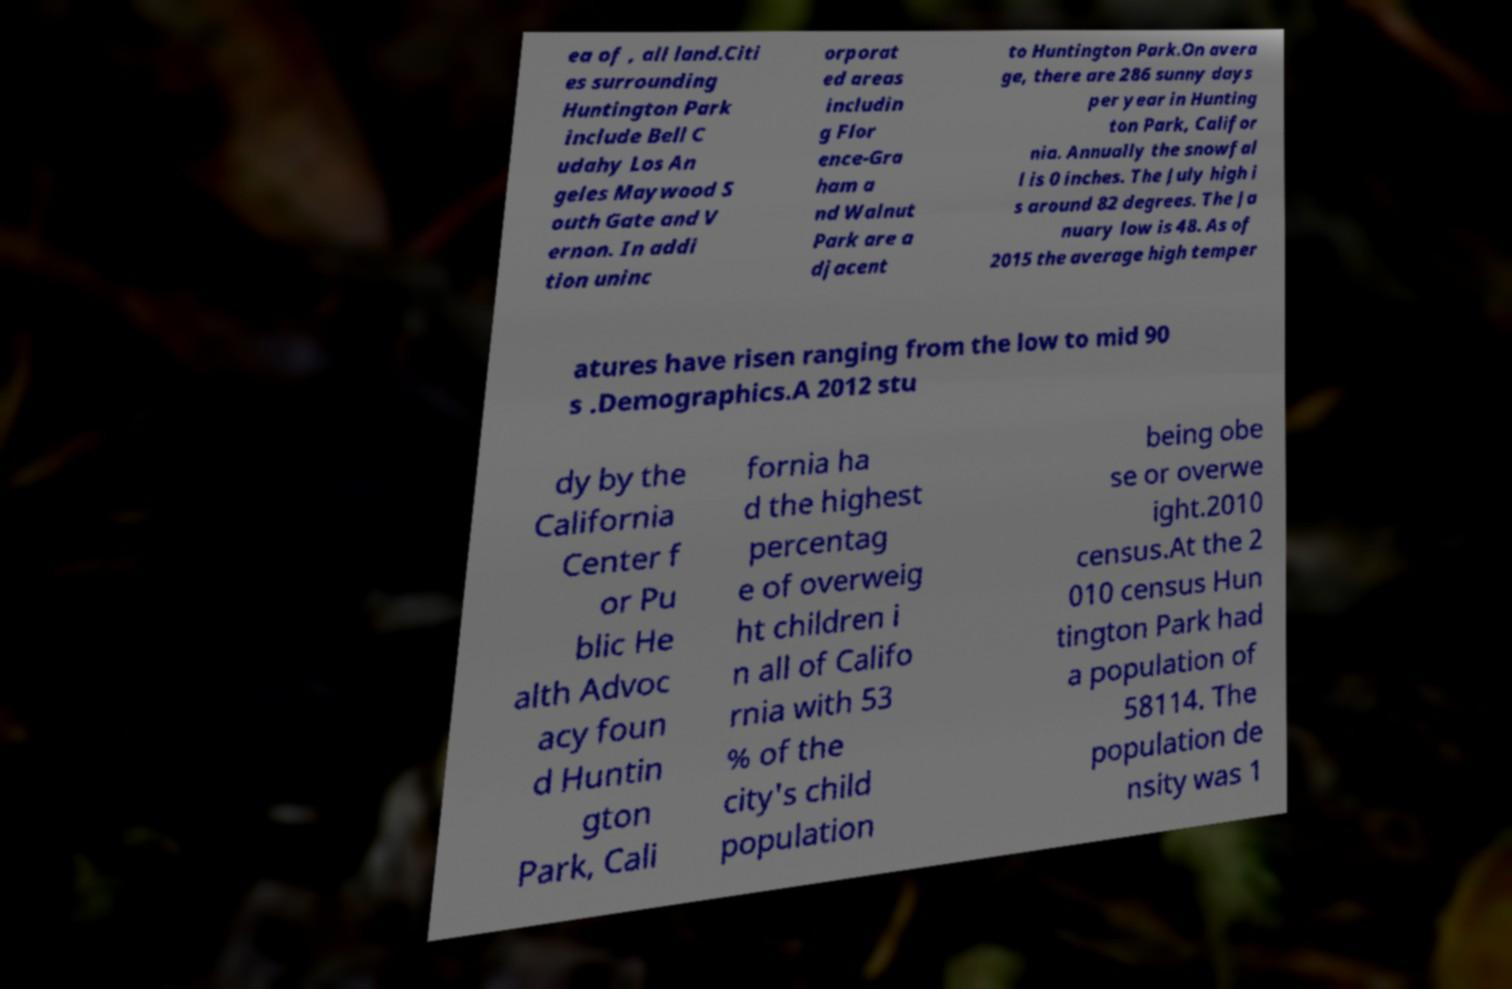For documentation purposes, I need the text within this image transcribed. Could you provide that? ea of , all land.Citi es surrounding Huntington Park include Bell C udahy Los An geles Maywood S outh Gate and V ernon. In addi tion uninc orporat ed areas includin g Flor ence-Gra ham a nd Walnut Park are a djacent to Huntington Park.On avera ge, there are 286 sunny days per year in Hunting ton Park, Califor nia. Annually the snowfal l is 0 inches. The July high i s around 82 degrees. The Ja nuary low is 48. As of 2015 the average high temper atures have risen ranging from the low to mid 90 s .Demographics.A 2012 stu dy by the California Center f or Pu blic He alth Advoc acy foun d Huntin gton Park, Cali fornia ha d the highest percentag e of overweig ht children i n all of Califo rnia with 53 % of the city's child population being obe se or overwe ight.2010 census.At the 2 010 census Hun tington Park had a population of 58114. The population de nsity was 1 